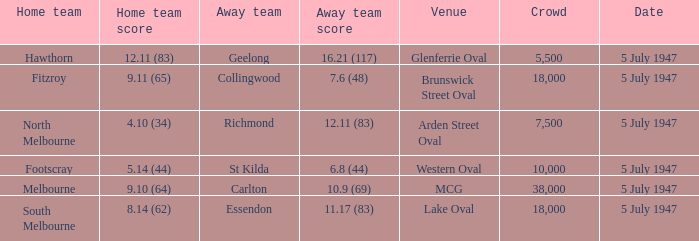What home team played an away team with a score of 6.8 (44)? Footscray. Could you help me parse every detail presented in this table? {'header': ['Home team', 'Home team score', 'Away team', 'Away team score', 'Venue', 'Crowd', 'Date'], 'rows': [['Hawthorn', '12.11 (83)', 'Geelong', '16.21 (117)', 'Glenferrie Oval', '5,500', '5 July 1947'], ['Fitzroy', '9.11 (65)', 'Collingwood', '7.6 (48)', 'Brunswick Street Oval', '18,000', '5 July 1947'], ['North Melbourne', '4.10 (34)', 'Richmond', '12.11 (83)', 'Arden Street Oval', '7,500', '5 July 1947'], ['Footscray', '5.14 (44)', 'St Kilda', '6.8 (44)', 'Western Oval', '10,000', '5 July 1947'], ['Melbourne', '9.10 (64)', 'Carlton', '10.9 (69)', 'MCG', '38,000', '5 July 1947'], ['South Melbourne', '8.14 (62)', 'Essendon', '11.17 (83)', 'Lake Oval', '18,000', '5 July 1947']]} 